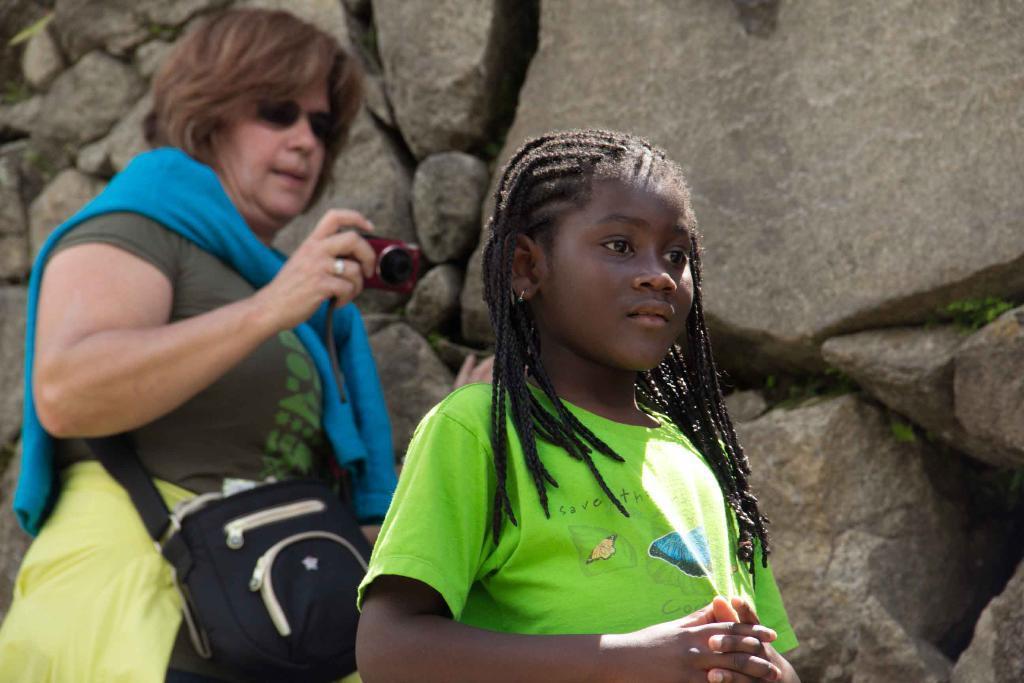Describe this image in one or two sentences. In the foreground of the picture there is a girl. In the background there is a woman wearing a bag and holding a camera. In the background it is rock. 